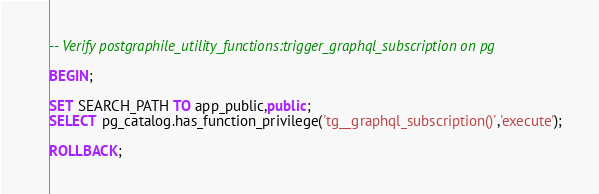Convert code to text. <code><loc_0><loc_0><loc_500><loc_500><_SQL_>-- Verify postgraphile_utility_functions:trigger_graphql_subscription on pg

BEGIN;

SET SEARCH_PATH TO app_public,public;
SELECT pg_catalog.has_function_privilege('tg__graphql_subscription()','execute');

ROLLBACK;
</code> 